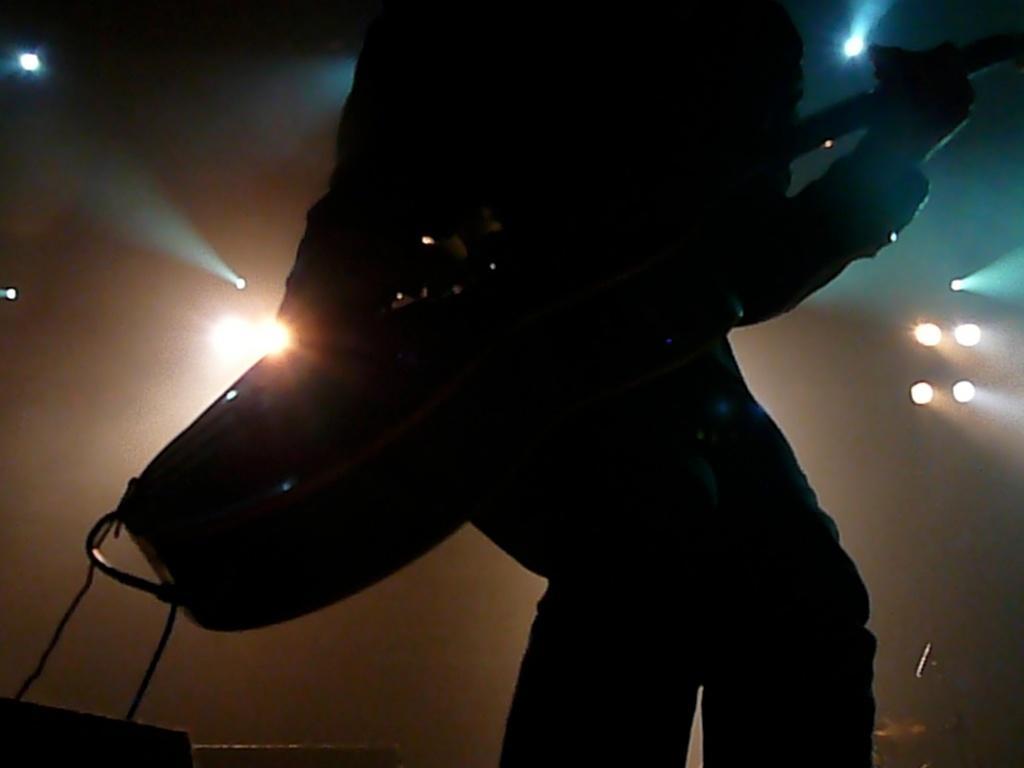Could you give a brief overview of what you see in this image? In the picture there is a person playing guitar, there are many lights present. 